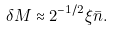<formula> <loc_0><loc_0><loc_500><loc_500>\delta M \approx 2 ^ { - 1 / 2 } \xi \bar { n } .</formula> 